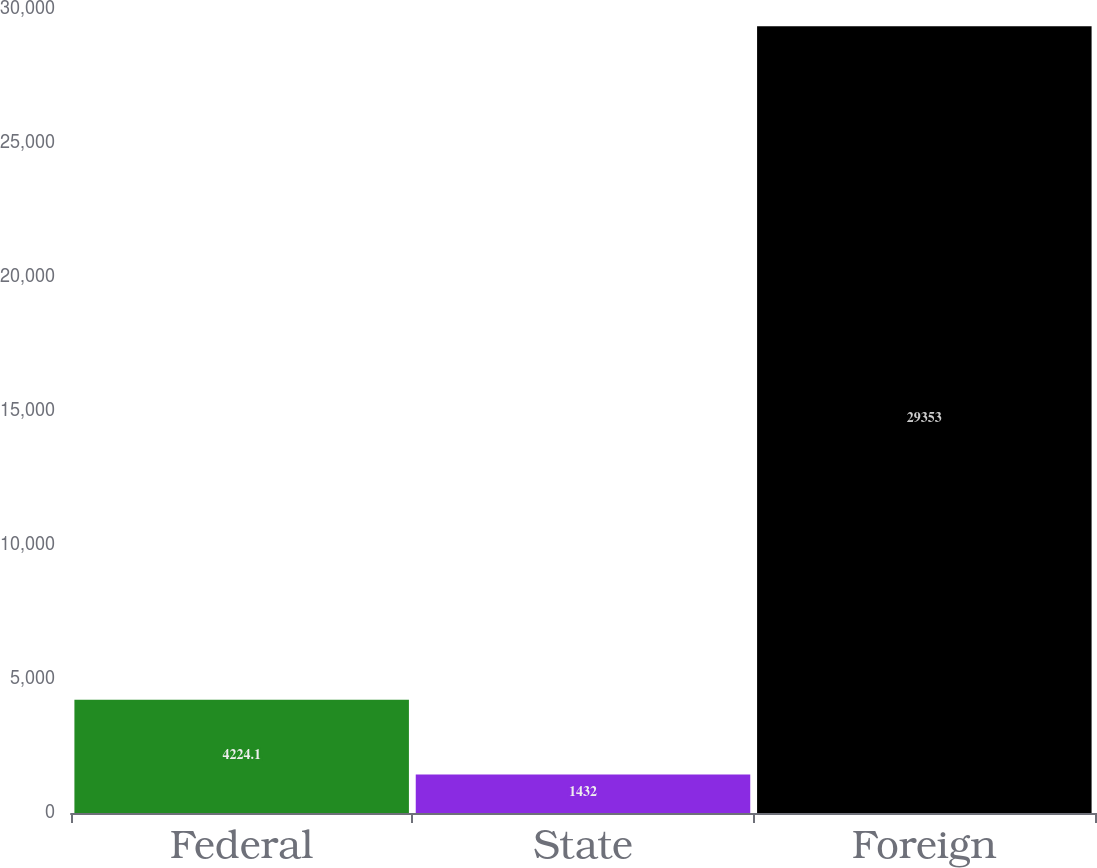Convert chart to OTSL. <chart><loc_0><loc_0><loc_500><loc_500><bar_chart><fcel>Federal<fcel>State<fcel>Foreign<nl><fcel>4224.1<fcel>1432<fcel>29353<nl></chart> 